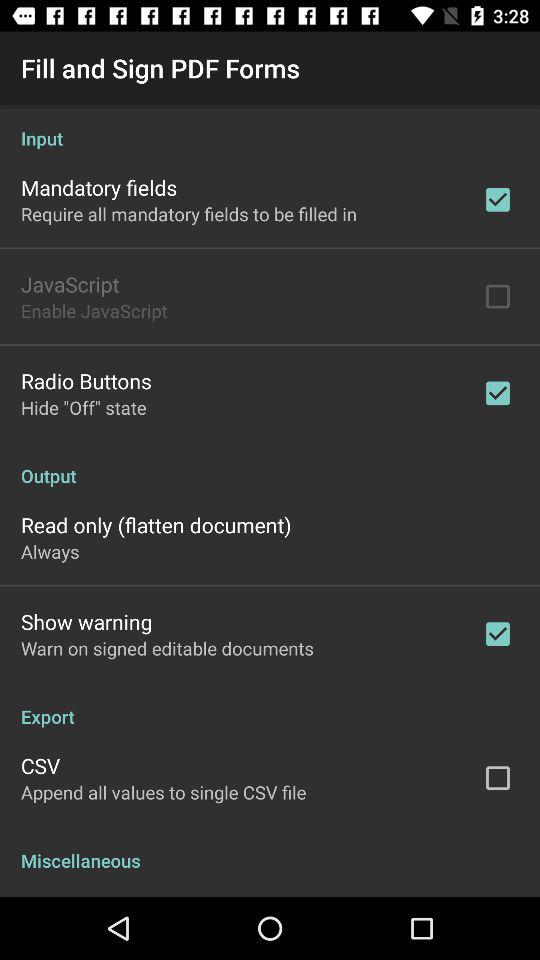What is the status of "Output"?
When the provided information is insufficient, respond with <no answer>. <no answer> 